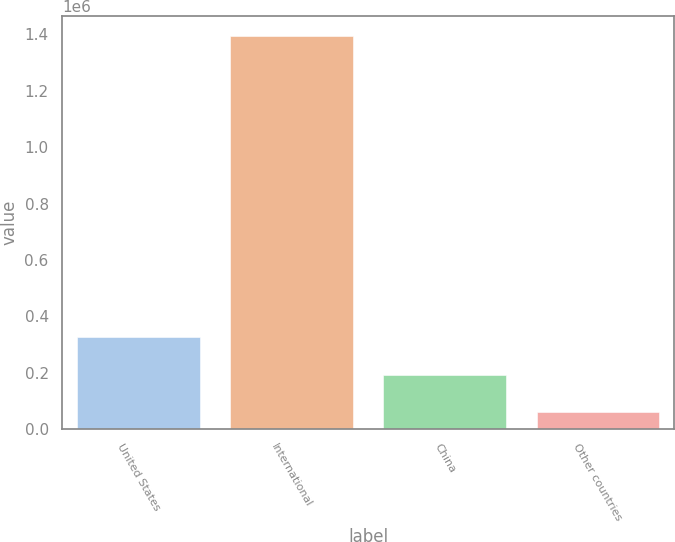Convert chart. <chart><loc_0><loc_0><loc_500><loc_500><bar_chart><fcel>United States<fcel>International<fcel>China<fcel>Other countries<nl><fcel>326684<fcel>1.39519e+06<fcel>193120<fcel>59557<nl></chart> 